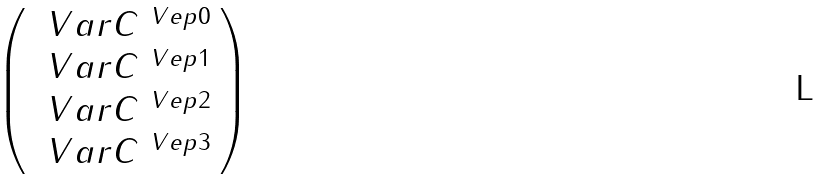Convert formula to latex. <formula><loc_0><loc_0><loc_500><loc_500>\left ( \begin{array} { c } \ V a r C ^ { \ V e p 0 } \\ \ V a r C ^ { \ V e p 1 } \\ \ V a r C ^ { \ V e p 2 } \\ \ V a r C ^ { \ V e p 3 } \end{array} \right )</formula> 